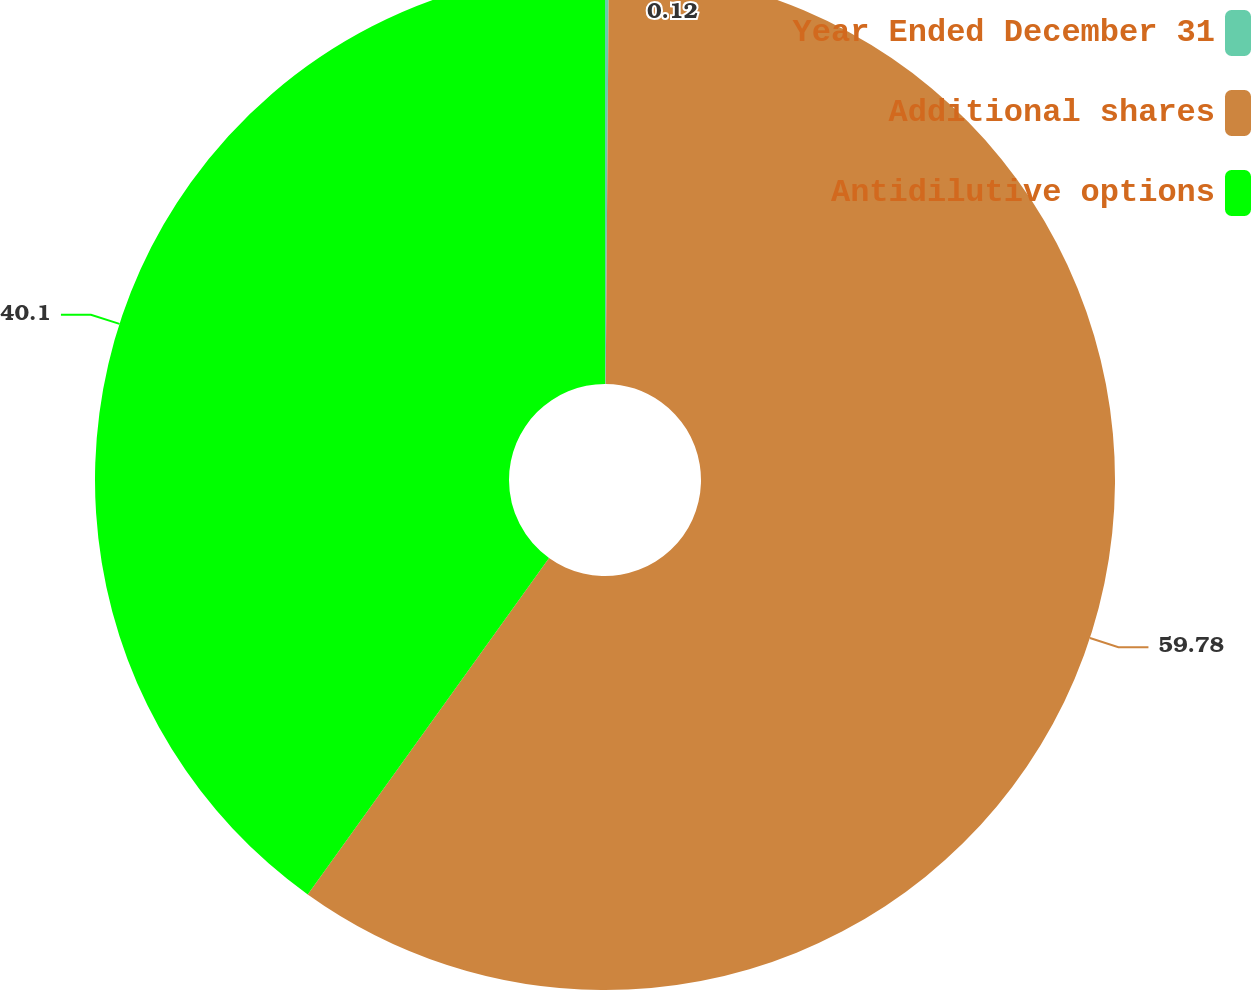Convert chart to OTSL. <chart><loc_0><loc_0><loc_500><loc_500><pie_chart><fcel>Year Ended December 31<fcel>Additional shares<fcel>Antidilutive options<nl><fcel>0.12%<fcel>59.79%<fcel>40.1%<nl></chart> 